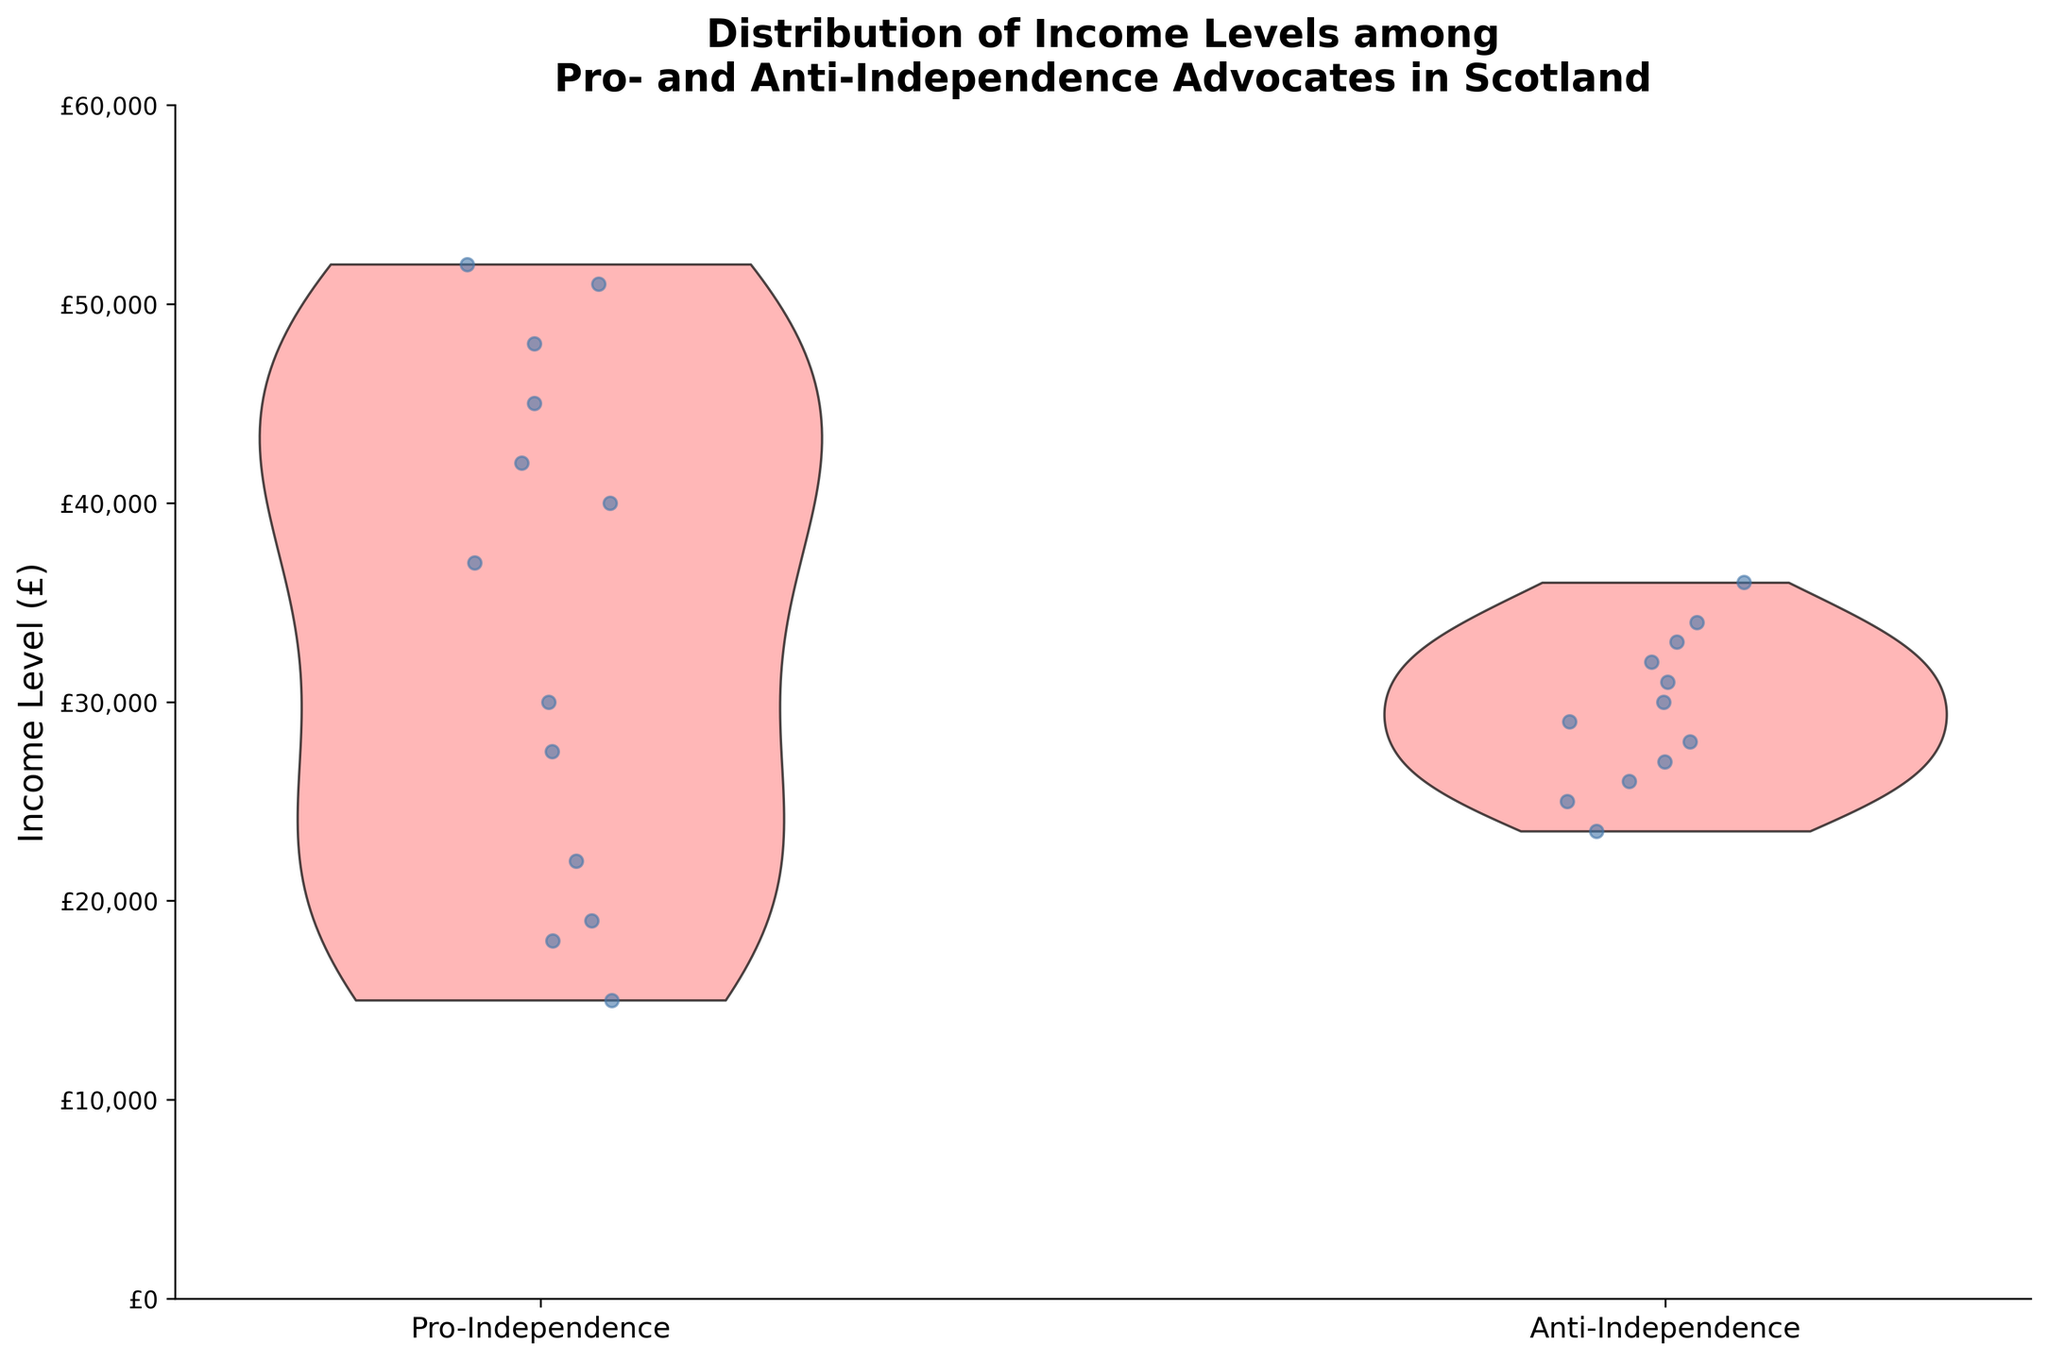What's the title of the plot? The title is prominently displayed at the top of the figure. It reads: "Distribution of Income Levels among Pro- and Anti-Independence Advocates in Scotland".
Answer: Distribution of Income Levels among Pro- and Anti-Independence Advocates in Scotland What does the X-axis represent? The X-axis has two categories labeled below it. They denote the groups being compared: "Pro-Independence" and "Anti-Independence".
Answer: The advocacy groups: "Pro-Independence" and "Anti-Independence" What is the Y-axis measuring? The Y-axis shows income levels, which range from £0 to £60,000. This is indicated by the labels along the Y-axis.
Answer: Income Levels (£) Which group appears to have a higher median income? The violin plot shows the distribution of incomes for each group. The density and spread of incomes for the Pro-Independence group appear to stretch higher on the Y-axis compared to the Anti-Independence group, suggesting a higher median.
Answer: Pro-Independence What range of incomes is most common for Pro-Independence advocates? By observing the density of the violin plot for Pro-Independence advocates, the most common income levels appear densely packed between £20,000 and £40,000.
Answer: £20,000 to £40,000 Are there any visible outliers in the income distribution of Pro-Independence advocates? Jittered points show individual incomes. While most points cluster within £20,000 to £40,000, some points extend out to higher incomes, indicating outliers.
Answer: Yes, at higher incomes How does the spread of income levels compare between the two groups? The violin plot for Pro-Independence advocates shows a wider spread and higher density at higher income levels compared to the Anti-Independence group's narrower spread and lower peak density.
Answer: Pro-Independence has a wider spread Is there significant overlap in income distributions between the two groups? The density and spread of the violin plots show that while there is some overlap in the middle ranges (£20,000 to £40,000), Pro-Independence advocates' incomes extend higher.
Answer: Yes, but Pro-Independence extends higher Do Pro-Independence advocates tend to have higher or lower incomes compared to Anti-Independence advocates? Comparing the violin plots, Pro-Independence advocates generally have higher income levels, as their distribution extends and peaks higher than that of Anti-Independence advocates.
Answer: Higher What's the income level for which the highest density of Pro-Independence advocates is observed? The peak density in the Pro-Independence violin plot, where it is widest, falls around the £30,000 mark.
Answer: £30,000 